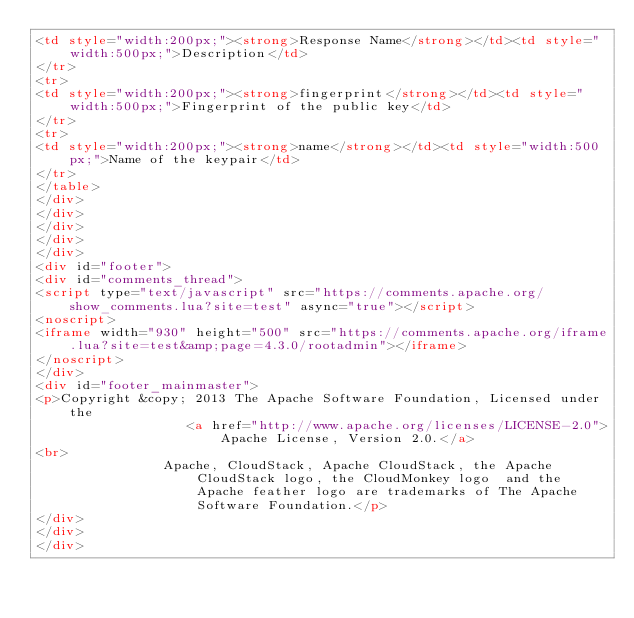<code> <loc_0><loc_0><loc_500><loc_500><_HTML_><td style="width:200px;"><strong>Response Name</strong></td><td style="width:500px;">Description</td>
</tr>
<tr>
<td style="width:200px;"><strong>fingerprint</strong></td><td style="width:500px;">Fingerprint of the public key</td>
</tr>
<tr>
<td style="width:200px;"><strong>name</strong></td><td style="width:500px;">Name of the keypair</td>
</tr>
</table>
</div>
</div>
</div>
</div>
</div>
<div id="footer">
<div id="comments_thread">
<script type="text/javascript" src="https://comments.apache.org/show_comments.lua?site=test" async="true"></script>
<noscript>
<iframe width="930" height="500" src="https://comments.apache.org/iframe.lua?site=test&amp;page=4.3.0/rootadmin"></iframe>
</noscript>
</div>
<div id="footer_mainmaster">
<p>Copyright &copy; 2013 The Apache Software Foundation, Licensed under the
                   <a href="http://www.apache.org/licenses/LICENSE-2.0">Apache License, Version 2.0.</a>
<br>
                Apache, CloudStack, Apache CloudStack, the Apache CloudStack logo, the CloudMonkey logo  and the Apache feather logo are trademarks of The Apache Software Foundation.</p>
</div>
</div>
</div></code> 